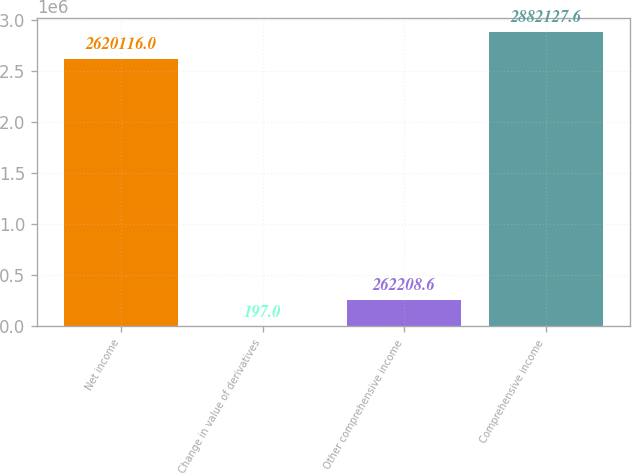Convert chart. <chart><loc_0><loc_0><loc_500><loc_500><bar_chart><fcel>Net income<fcel>Change in value of derivatives<fcel>Other comprehensive income<fcel>Comprehensive income<nl><fcel>2.62012e+06<fcel>197<fcel>262209<fcel>2.88213e+06<nl></chart> 